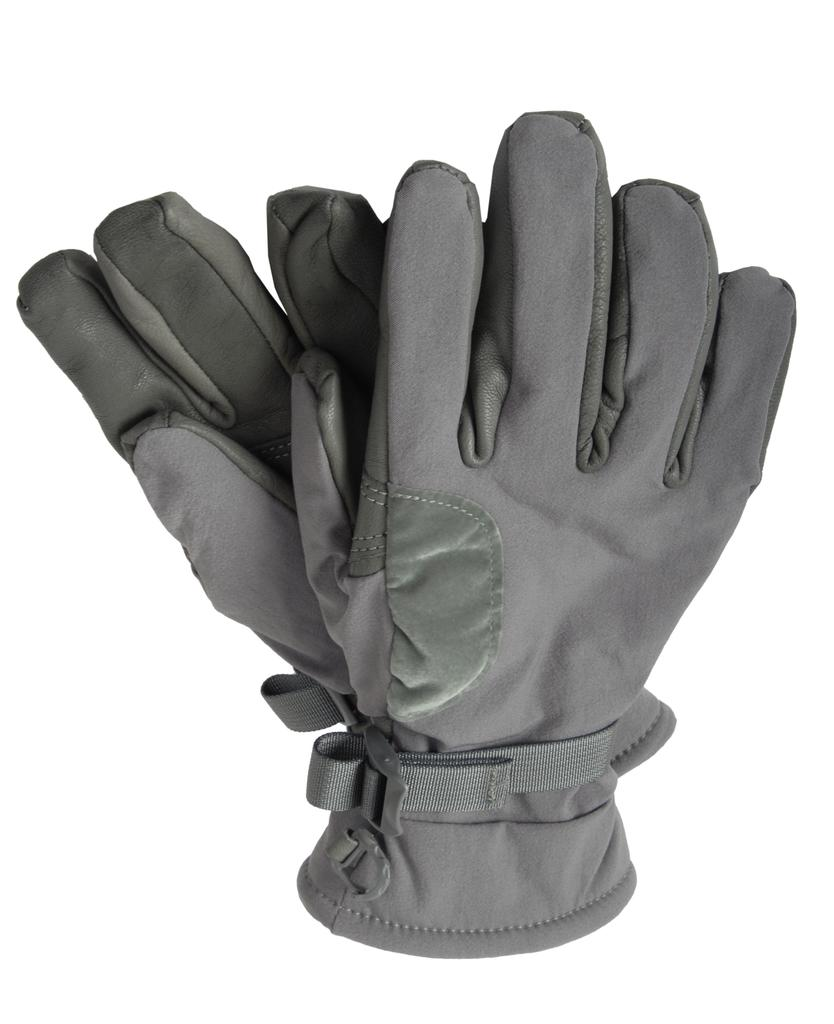What type of clothing item is present in the image? There are gloves in the image. What color are the gloves? The gloves are gray in color. How are the gloves positioned in the image? The gloves are placed on another. Is the cub playing with the gloves in the image? There is no cub present in the image, so it cannot be playing with the gloves. 